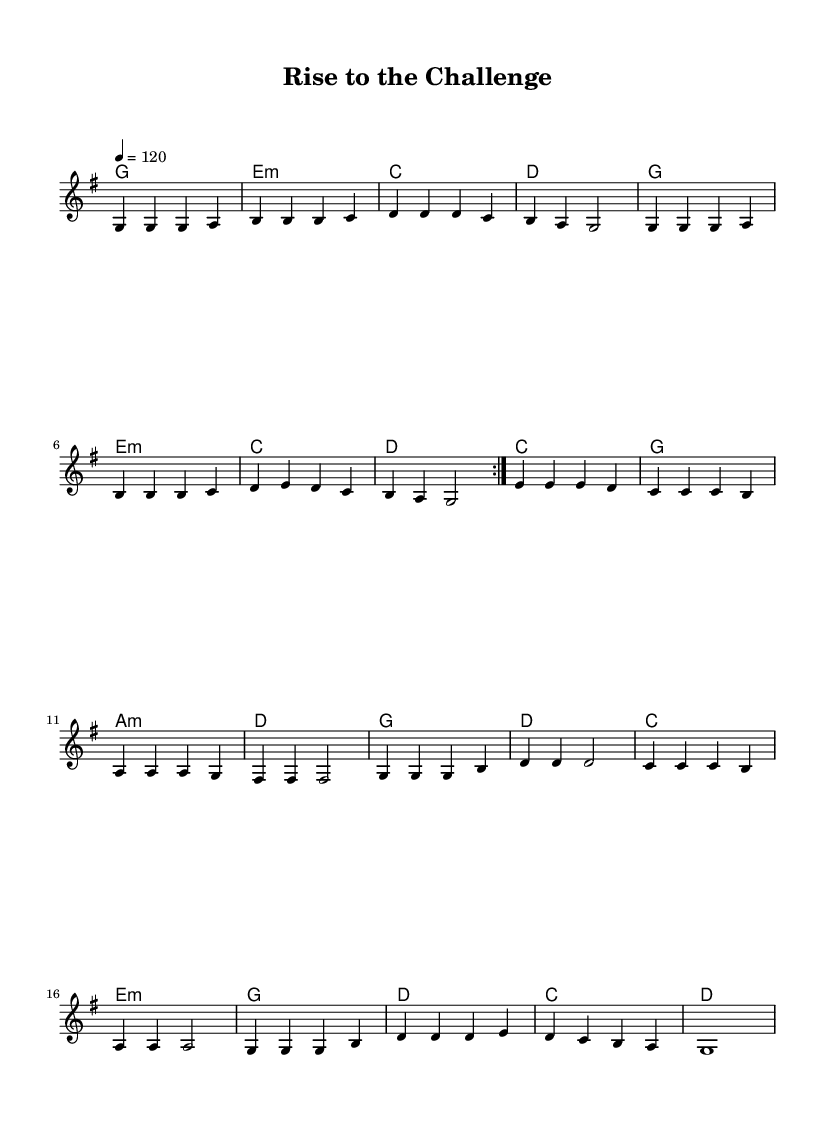What is the key signature of this music? The key signature is G major, which has one sharp (F#). You can identify the key signature by looking at the beginning of the staff, where the sharp is placed.
Answer: G major What is the time signature of this piece? The time signature is 4/4, indicated at the beginning of the staff. This means there are four beats in each measure, and a quarter note receives one beat.
Answer: 4/4 What is the tempo marking of this piece? The tempo marking is 120 beats per minute, found in the tempo indication right after the time signature. This specifies how fast the piece should be played.
Answer: 120 How many measures are there in the main melody? The main melody contains sixteen measures as counted through the repeated sections and each line of music.
Answer: 16 What is the name of this song? The title of the song is "Rise to the Challenge," located at the beginning of the sheet music. This indicates the name of the composition and is usually prominently displayed.
Answer: Rise to the Challenge How many verses are there in this song? There is one verse in this song, which can be identified in the lyrics section where it is marked specifically as a verse.
Answer: 1 What is the main theme of the chorus? The main theme of the chorus emphasizes taking action towards challenges and professional growth, which is clearly articulated in the words of the chorus section.
Answer: Seize the day 